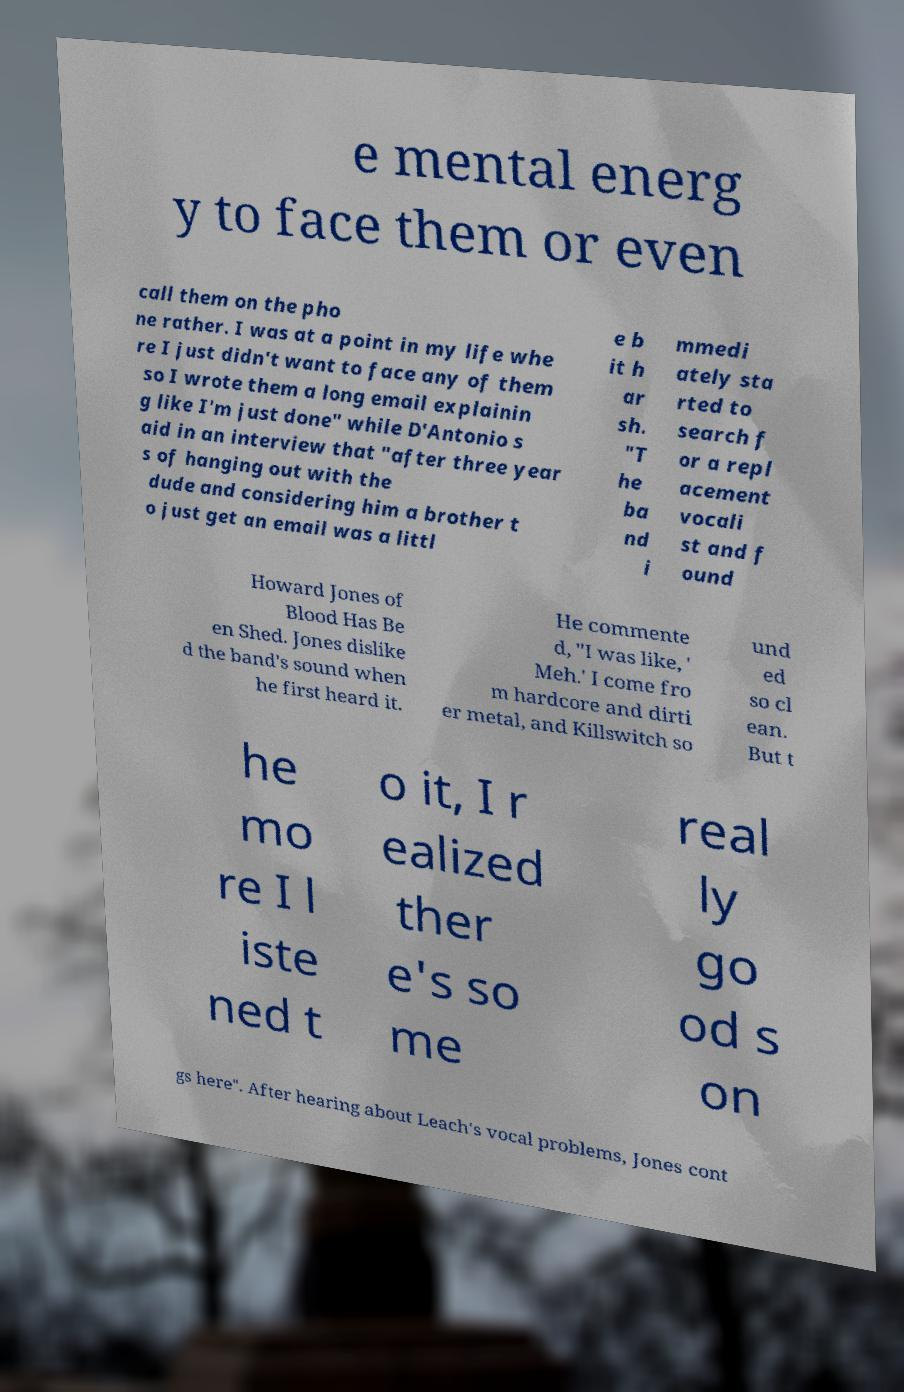For documentation purposes, I need the text within this image transcribed. Could you provide that? e mental energ y to face them or even call them on the pho ne rather. I was at a point in my life whe re I just didn't want to face any of them so I wrote them a long email explainin g like I'm just done" while D'Antonio s aid in an interview that "after three year s of hanging out with the dude and considering him a brother t o just get an email was a littl e b it h ar sh. "T he ba nd i mmedi ately sta rted to search f or a repl acement vocali st and f ound Howard Jones of Blood Has Be en Shed. Jones dislike d the band's sound when he first heard it. He commente d, "I was like, ' Meh.' I come fro m hardcore and dirti er metal, and Killswitch so und ed so cl ean. But t he mo re I l iste ned t o it, I r ealized ther e's so me real ly go od s on gs here". After hearing about Leach's vocal problems, Jones cont 